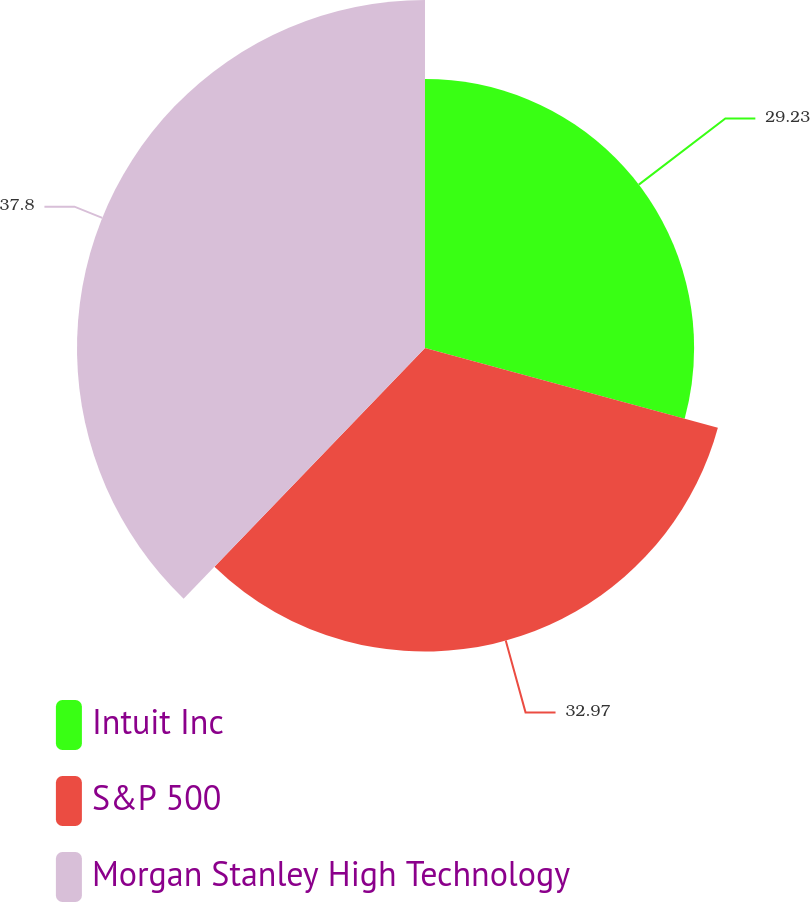Convert chart to OTSL. <chart><loc_0><loc_0><loc_500><loc_500><pie_chart><fcel>Intuit Inc<fcel>S&P 500<fcel>Morgan Stanley High Technology<nl><fcel>29.23%<fcel>32.97%<fcel>37.8%<nl></chart> 